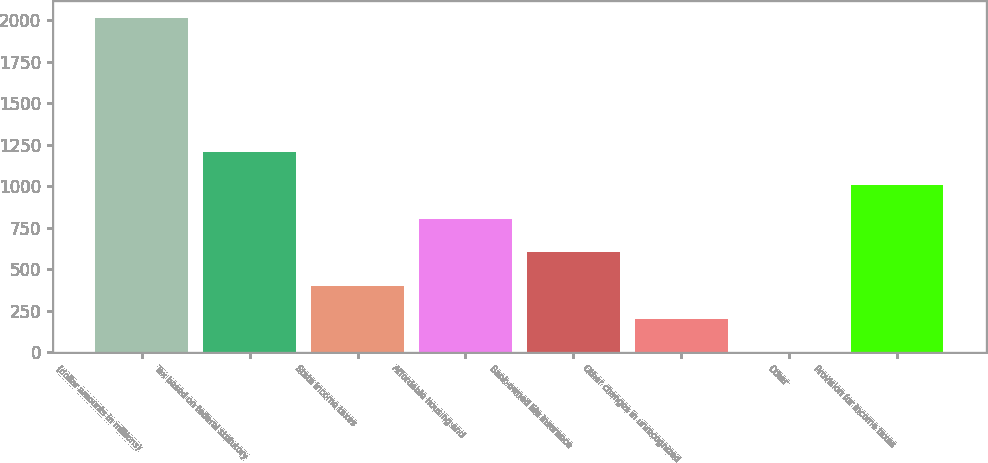<chart> <loc_0><loc_0><loc_500><loc_500><bar_chart><fcel>(dollar amounts in millions)<fcel>Tax based on federal statutory<fcel>State income taxes<fcel>Affordable housing and<fcel>Bank-owned life insurance<fcel>Other changes in unrecognized<fcel>Other<fcel>Provision for income taxes<nl><fcel>2014<fcel>1208.44<fcel>402.88<fcel>805.66<fcel>604.27<fcel>201.49<fcel>0.1<fcel>1007.05<nl></chart> 